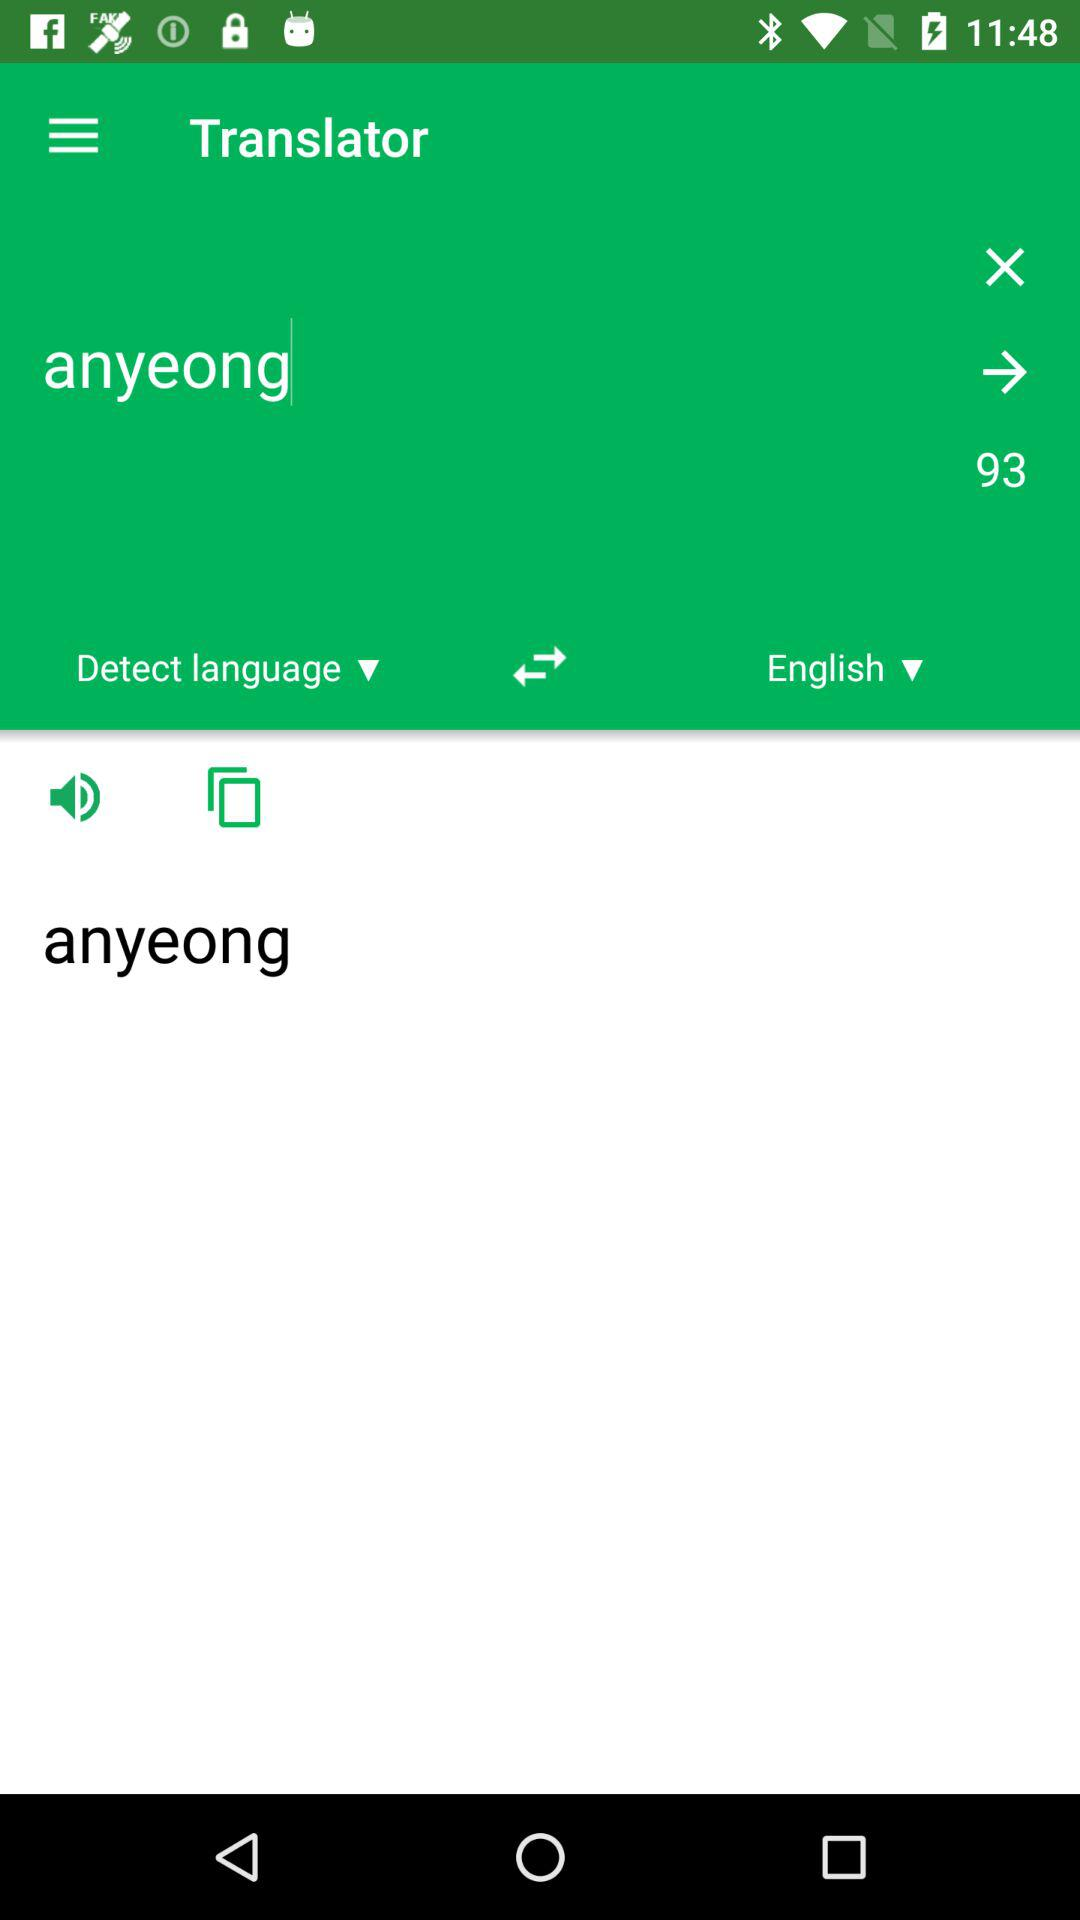What is the selected language? The selected language is English. 